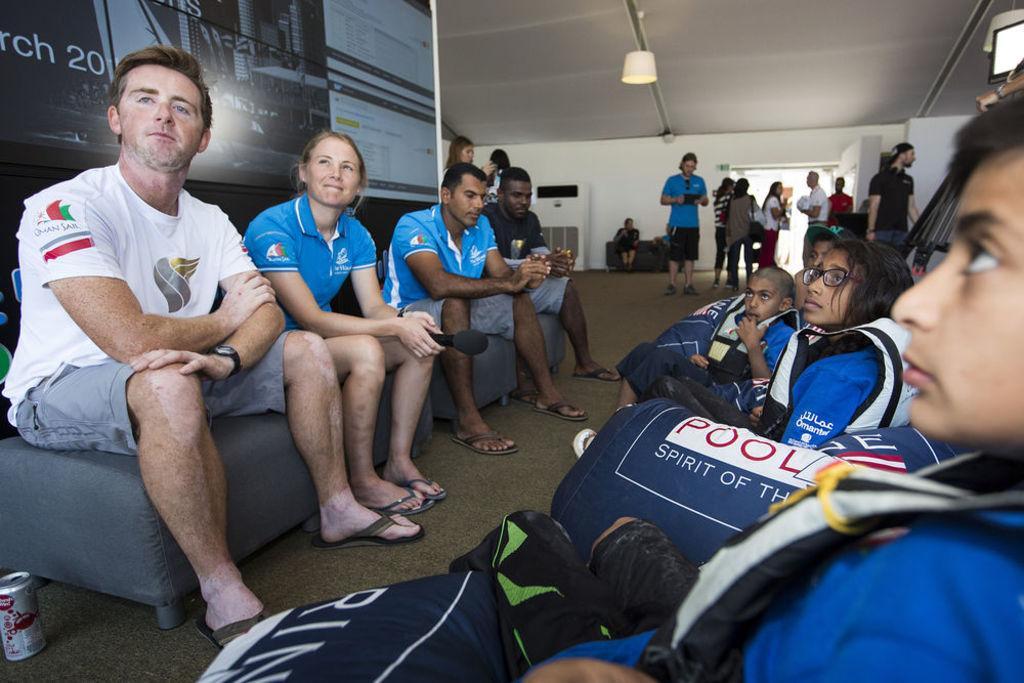Could you give a brief overview of what you see in this image? In this image I can see few people sitting on the left side of the image and on the right side of the image. At the top of the image I can see a false ceiling with a light and few people are standing in the center of the image and there is a banner behind the people sitting.  